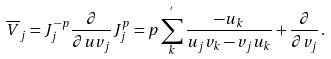Convert formula to latex. <formula><loc_0><loc_0><loc_500><loc_500>\overline { V } _ { j } = J _ { j } ^ { - p } \frac { \partial } { \partial u v _ { j } } J _ { j } ^ { p } = p \sum _ { k } ^ { ^ { \prime } } \frac { - u _ { k } } { u _ { j } v _ { k } - v _ { j } u _ { k } } + \frac { \partial } { \partial v _ { j } } \, .</formula> 